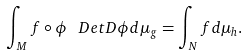Convert formula to latex. <formula><loc_0><loc_0><loc_500><loc_500>\int _ { M } f \circ \phi \, \ D e t { D \phi } d \mu _ { g } = \int _ { N } f d \mu _ { h } .</formula> 